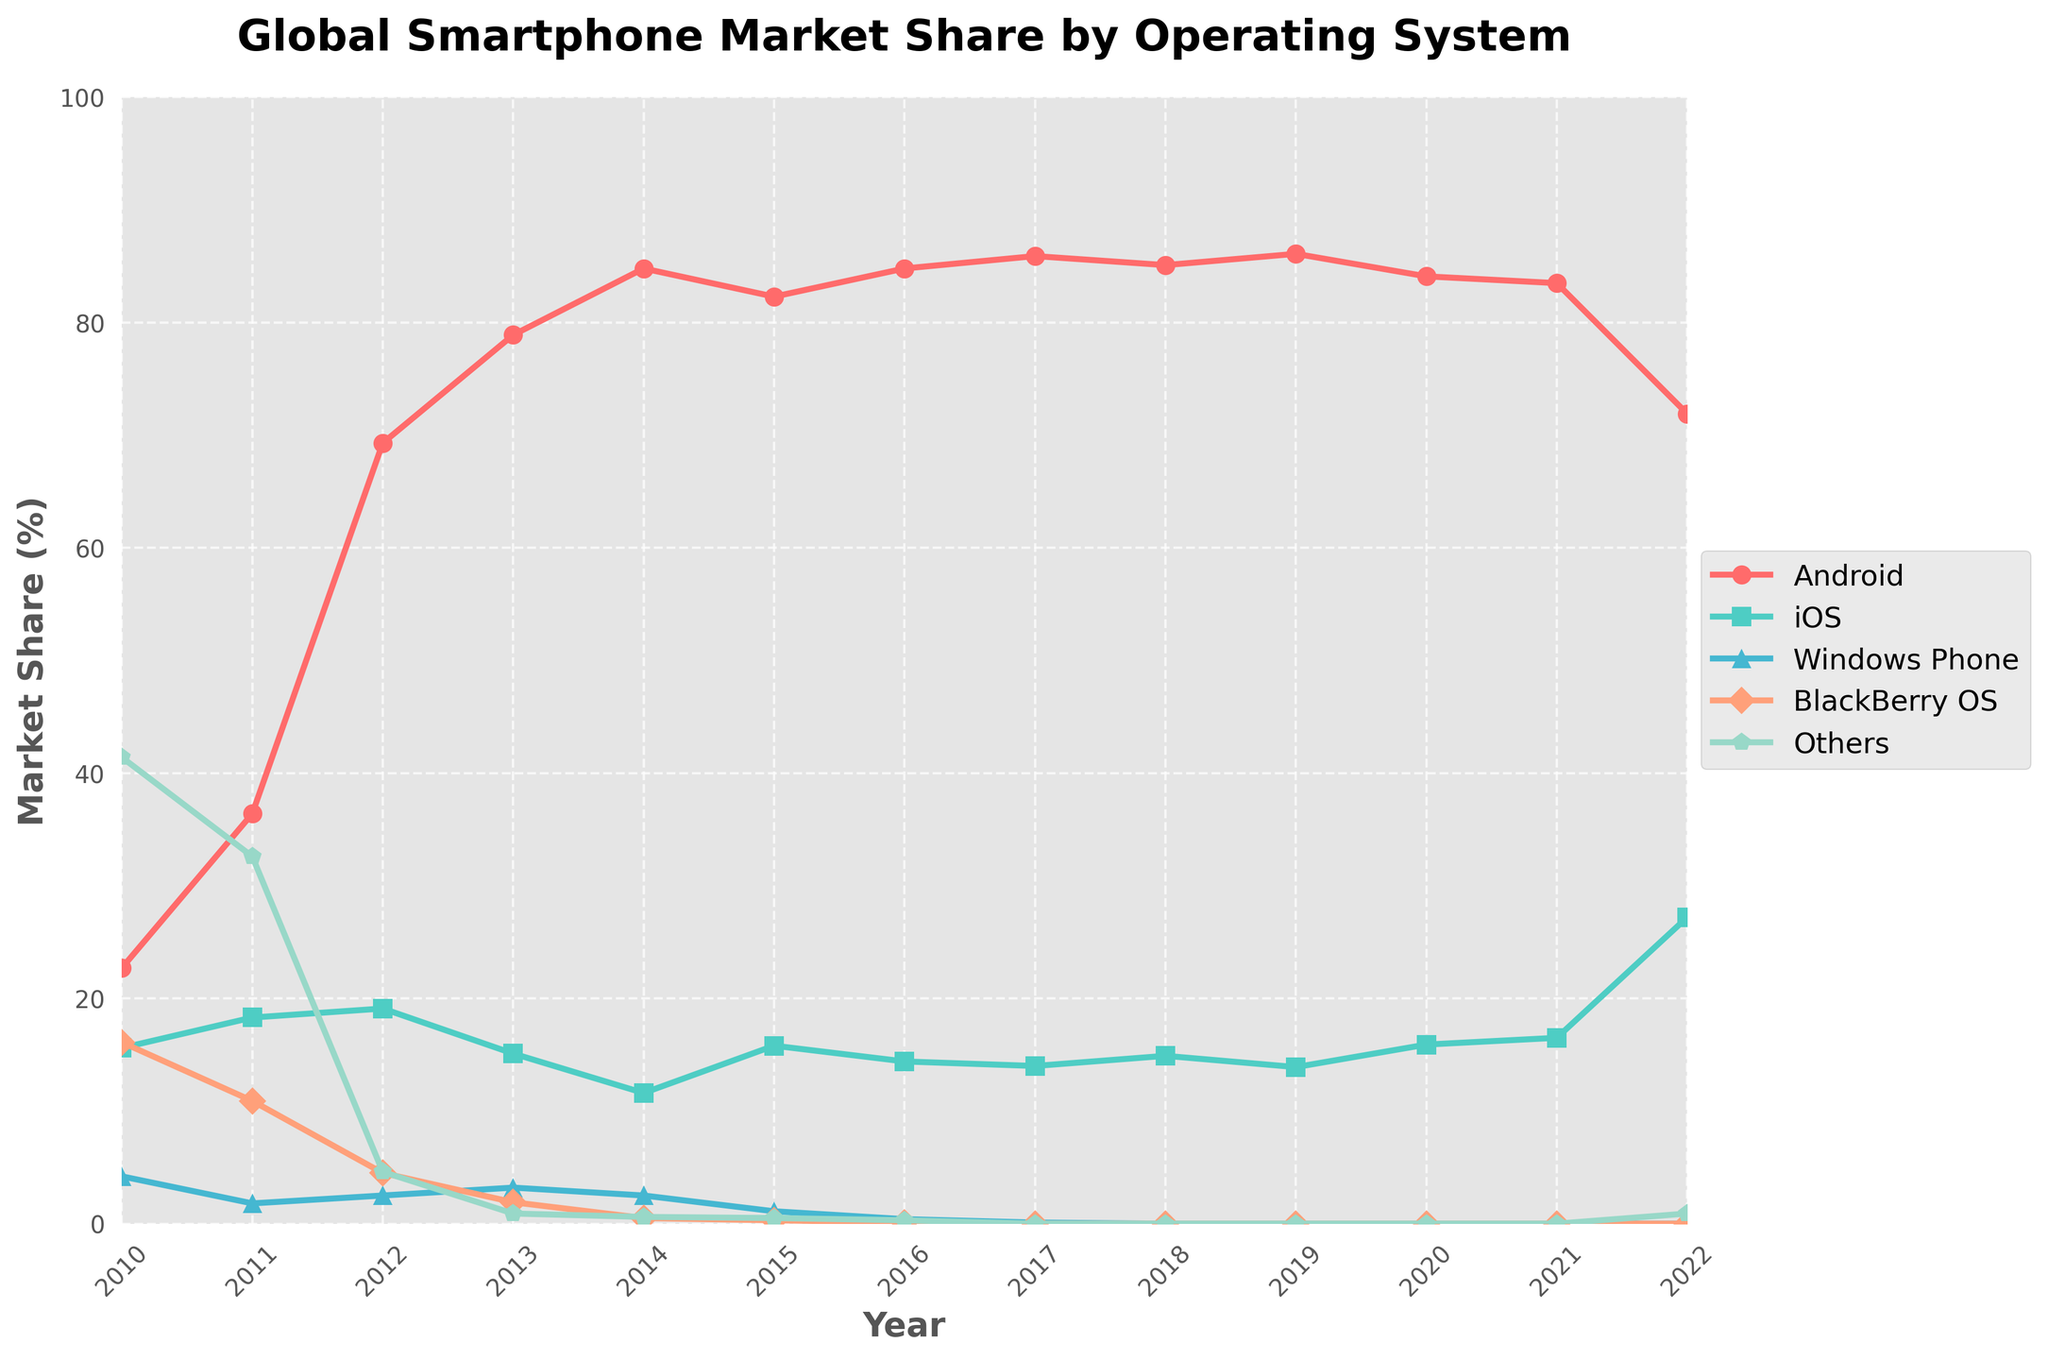What was the market share of Android in 2010, and how did it change by 2022? In 2010, Android had a market share of 22.7%. By 2022, its market share changed to 71.9%. The difference in market share is calculated by subtracting the market share in 2010 from the market share in 2022: 71.9% - 22.7% = 49.2%.
Answer: Increased by 49.2% Which operating system had the second highest market share in 2020, and what was that share? The figure shows that, in 2020, the second highest market share was held by iOS. The market share was 15.9%.
Answer: iOS, 15.9% How did the market share of Windows Phone change from 2011 to 2017? The market share of Windows Phone in 2011 was 1.8%. By 2017, it dropped to 0.1%. To find the change, we subtract the 2017 value from the 2011 value: 1.8% - 0.1% = 1.7%.
Answer: Decreased by 1.7% What is the average market share of BlackBerry OS from 2010 to 2014? To find the average market share of BlackBerry OS from 2010 to 2014, add the market share values for the specified years: (16.1 + 10.9 + 4.5 + 1.9 + 0.5) = 33.9%. Then, divide by the number of years: 33.9% / 5 = 6.78%.
Answer: 6.78% Compare the market share trend of iOS and Android from 2016 to 2022. Which one increased and which one decreased? From 2016 to 2022, iOS market share increased from 14.4% to 27.2%. In contrast, Android market share decreased from 84.8% to 71.9%. Therefore, iOS increased and Android decreased.
Answer: iOS increased, Android decreased Among all operating systems, which one had the most stable market share from 2010 to 2022? The figure shows that "Others" had a very low and stable market share close to 0% from 2013 onwards. Despite starting at 41.4% in 2010, the value converges to nearly unchanged from 2013 to 2022.
Answer: Others During which year did Android surpass an 80% market share first? The figure indicates that Android first surpassed an 80% market share in 2013 when it reached 78.9% and then climbed to 84.8% in 2014.
Answer: 2014 In the year 2015, what is the combined market share of Windows Phone and BlackBerry OS? The market share of Windows Phone in 2015 was 1.1% and BlackBerry OS was 0.3%. Adding them together: 1.1% + 0.3% = 1.4%.
Answer: 1.4% How many years does iOS have a market share above 15%? iOS had a market share above 15% during the years: 2010 (15.6%), 2011 (18.3%), 2012 (19.1%), 2015 (15.8%), 2020 (15.9%), 2021 (16.5%), and 2022 (27.2%). Counting these years, there are 7 years.
Answer: 7 years 